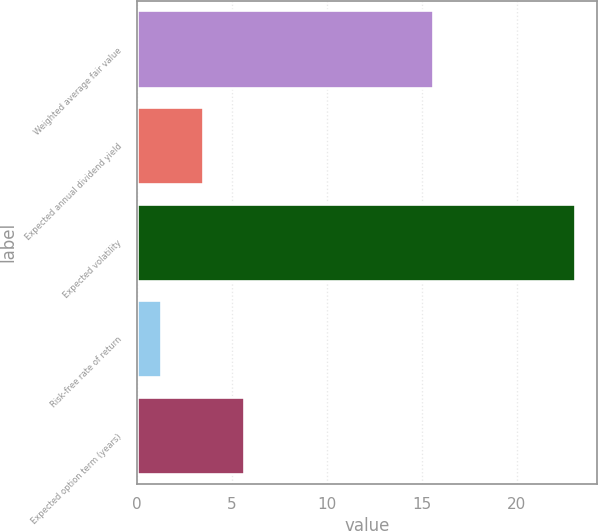Convert chart. <chart><loc_0><loc_0><loc_500><loc_500><bar_chart><fcel>Weighted average fair value<fcel>Expected annual dividend yield<fcel>Expected volatility<fcel>Risk-free rate of return<fcel>Expected option term (years)<nl><fcel>15.59<fcel>3.47<fcel>23.07<fcel>1.29<fcel>5.65<nl></chart> 